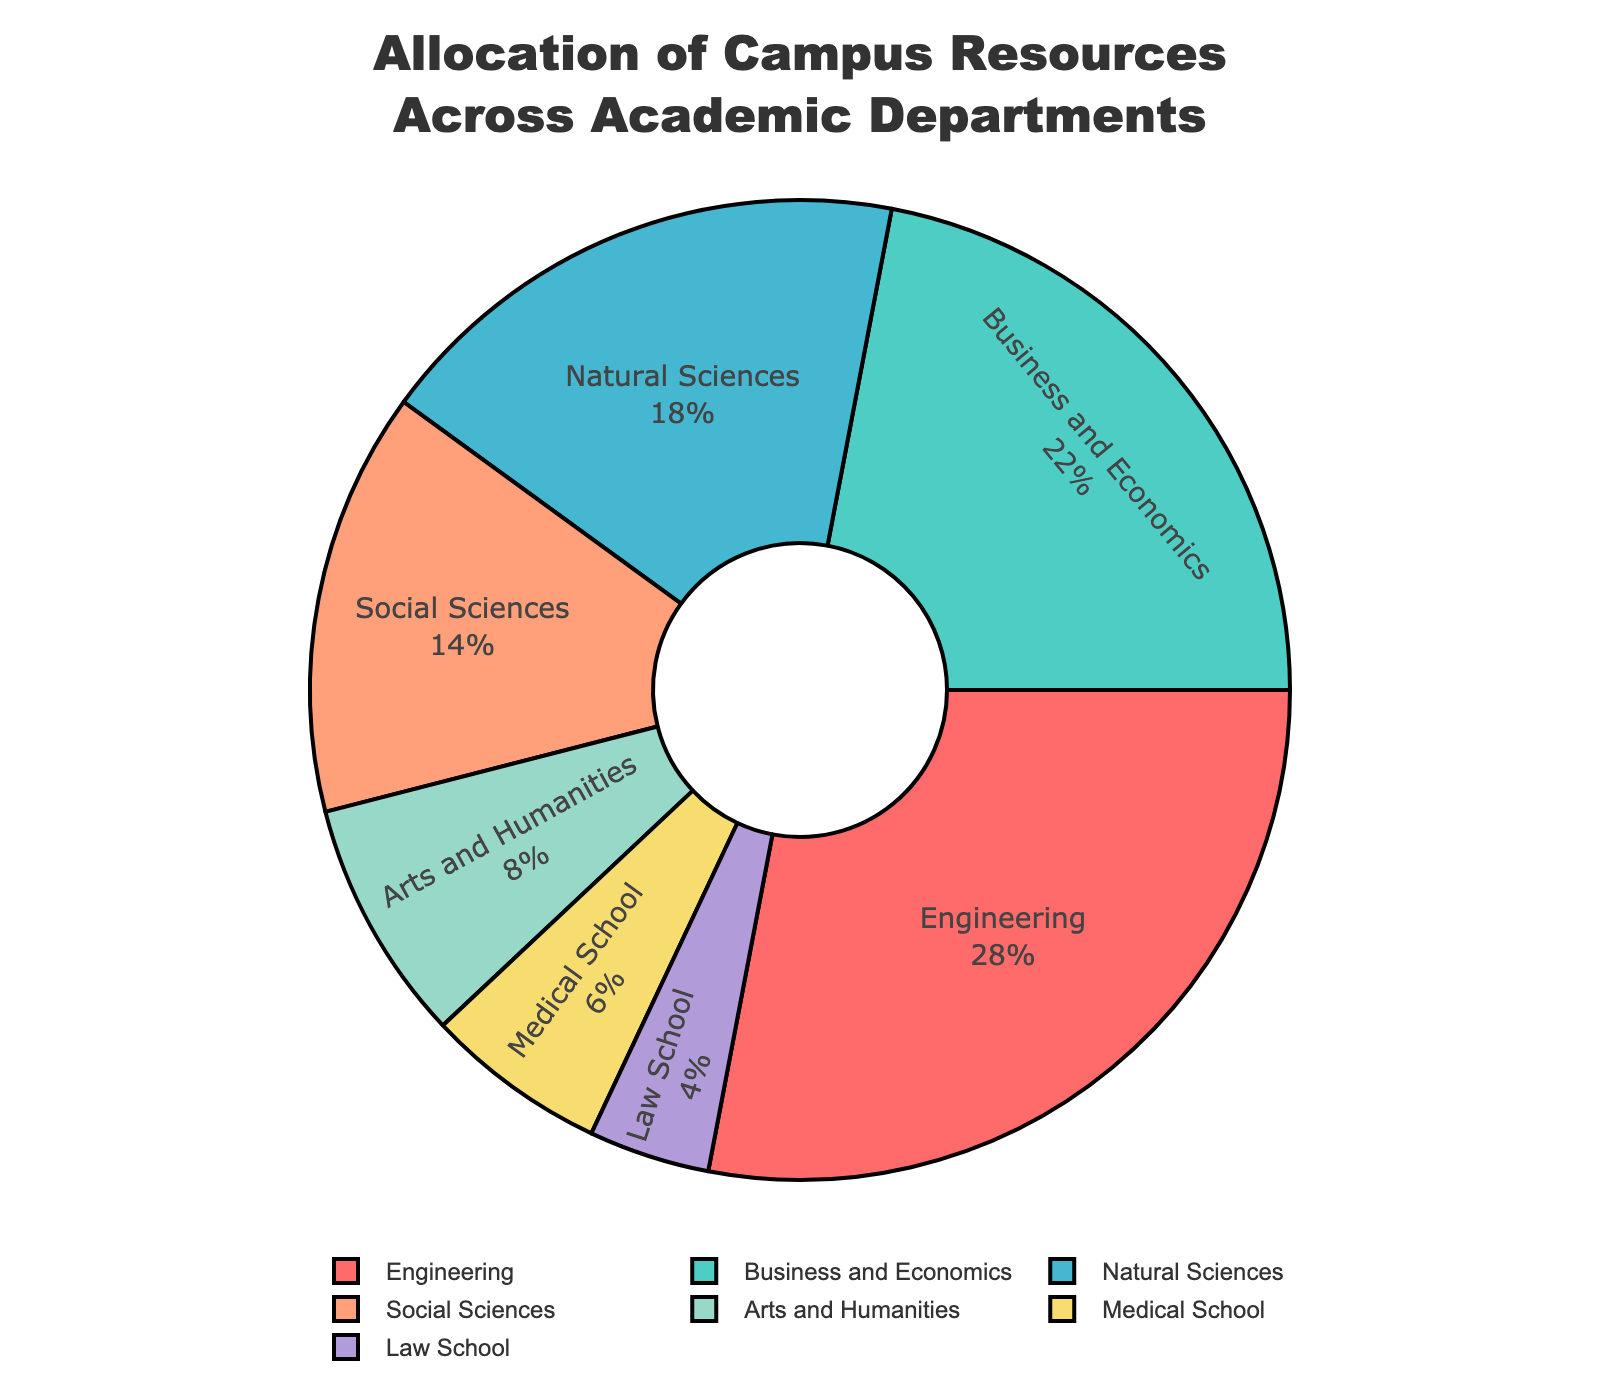Which department receives the highest allocation of resources? The pie chart shows the percentage allocation of campus resources across various departments. The Engineering department has the highest allocation of 28%.
Answer: Engineering What is the combined resource allocation for Business and Economics and Social Sciences? The pie chart shows that Business and Economics is allocated 22% and Social Sciences is allocated 14%. Adding these together gives 22% + 14% = 36%.
Answer: 36% How much more resource allocation does the Engineering department receive compared to the Medical School? The pie chart shows that Engineering receives 28% and Medical School receives 6%. The difference is 28% - 6% = 22%.
Answer: 22% Which department gets the least amount of resource allocation? On the pie chart, the Law School has the smallest segment, representing 4% of the total allocation.
Answer: Law School What is the combined percentage allocation for Arts and Humanities and Law School? The pie chart shows that Arts and Humanities is allocated 8% and Law School is allocated 4%. Adding these together gives 8% + 4% = 12%.
Answer: 12% What percentage of resources are allocated to departments other than Engineering, Business and Economics, and Natural Sciences? The pie chart shows the allocations for Engineering (28%), Business and Economics (22%), and Natural Sciences (18%). Summing these, we get 28% + 22% + 18% = 68%. Therefore, resources allocated to other departments are 100% - 68% = 32%.
Answer: 32% How does the resource allocation for Social Sciences compare with that for Natural Sciences? The pie chart shows that Social Sciences receive 14% and Natural Sciences receive 18%. Natural Sciences receive a greater share by 18% - 14% = 4%.
Answer: Natural Sciences receive 4% more If the Engineering allocation was reduced by 5% and equally distributed among Law School and Medical School, what would their new allocations be? Current allocations: Engineering (28%), Law School (4%), Medical School (6%). Reducing Engineering by 5% gives 23%. Distributing 5% equally: 2.5% to Law School and 2.5% to Medical School. New allocations: Law School = 4% + 2.5% = 6.5%, Medical School = 6% + 2.5% = 8.5%.
Answer: Law School: 6.5%, Medical School: 8.5% What is the total percentage allocation for the departments that receive less than 10% each? The pie chart shows that Arts and Humanities receive 8%, Medical School 6%, and Law School 4%. Adding these together gives 8% + 6% + 4% = 18%.
Answer: 18% 